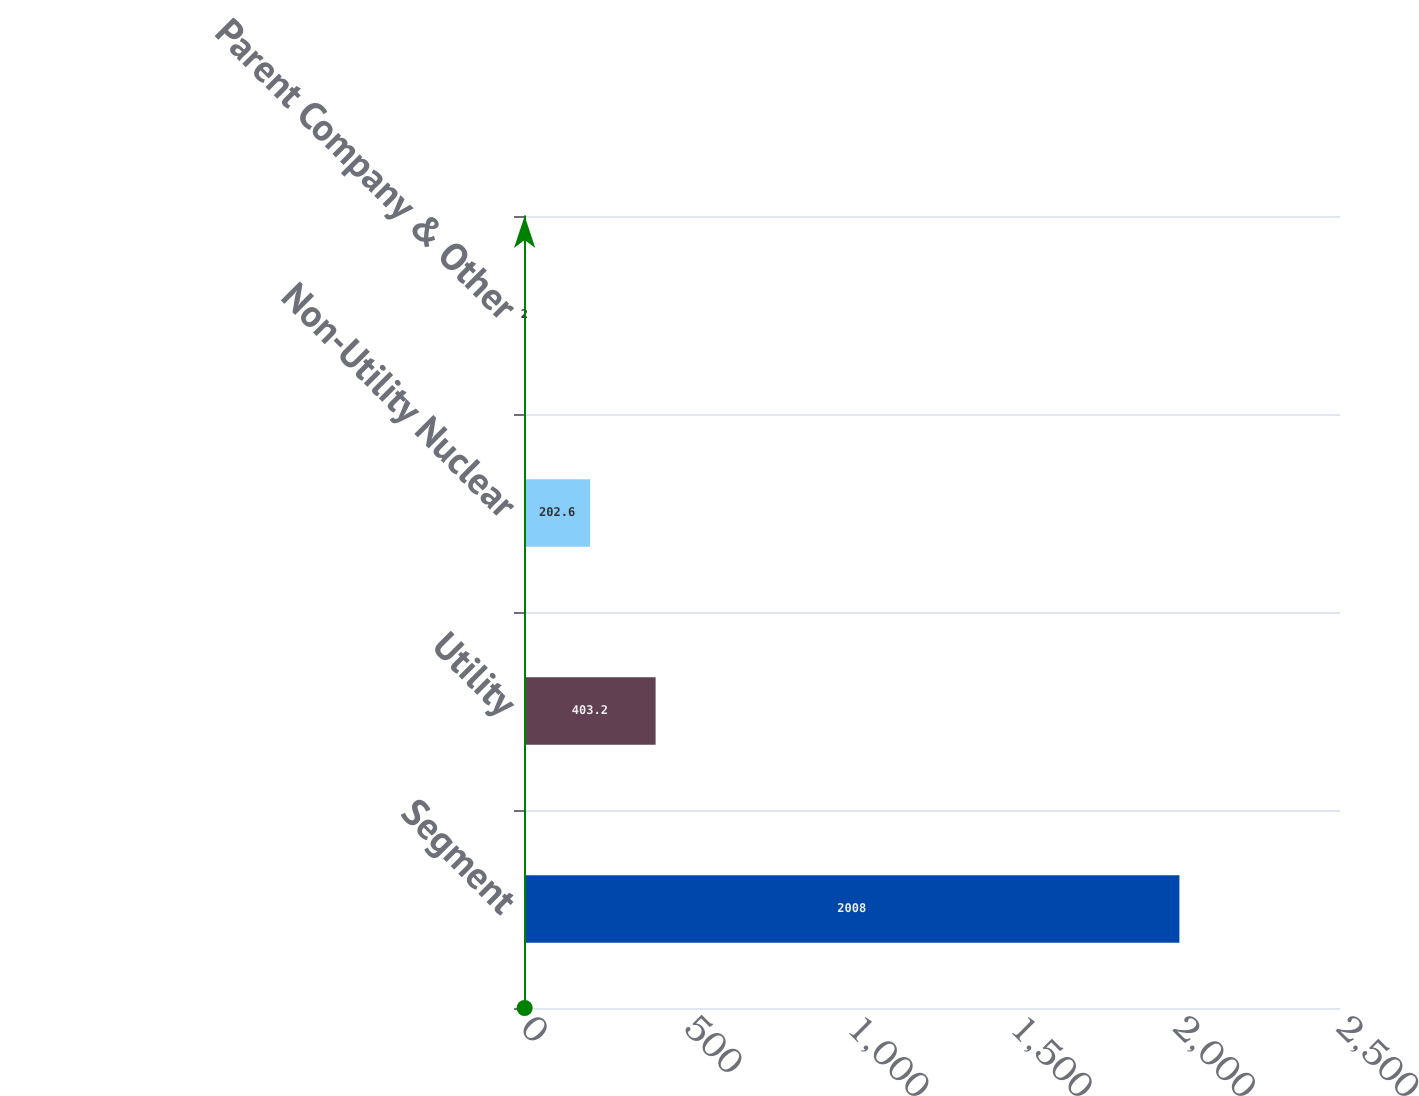Convert chart to OTSL. <chart><loc_0><loc_0><loc_500><loc_500><bar_chart><fcel>Segment<fcel>Utility<fcel>Non-Utility Nuclear<fcel>Parent Company & Other<nl><fcel>2008<fcel>403.2<fcel>202.6<fcel>2<nl></chart> 